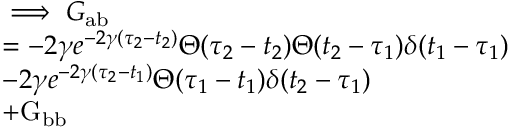Convert formula to latex. <formula><loc_0><loc_0><loc_500><loc_500>\begin{array} { r l } & { \implies G _ { a b } } \\ & { = - 2 \gamma e ^ { - 2 \gamma ( \tau _ { 2 } - t _ { 2 } ) } \Theta ( \tau _ { 2 } - t _ { 2 } ) \Theta ( t _ { 2 } - \tau _ { 1 } ) \delta ( t _ { 1 } - \tau _ { 1 } ) } \\ & { - 2 \gamma e ^ { - 2 \gamma ( \tau _ { 2 } - t _ { 1 } ) } \Theta ( \tau _ { 1 } - t _ { 1 } ) \delta ( t _ { 2 } - \tau _ { 1 } ) } \\ & { + G _ { b b } } \end{array}</formula> 